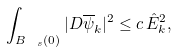<formula> <loc_0><loc_0><loc_500><loc_500>\int _ { B _ { \ s } ( 0 ) } | D { \overline { \psi } } _ { k } | ^ { 2 } \leq c \, { \hat { E } } _ { k } ^ { 2 } ,</formula> 